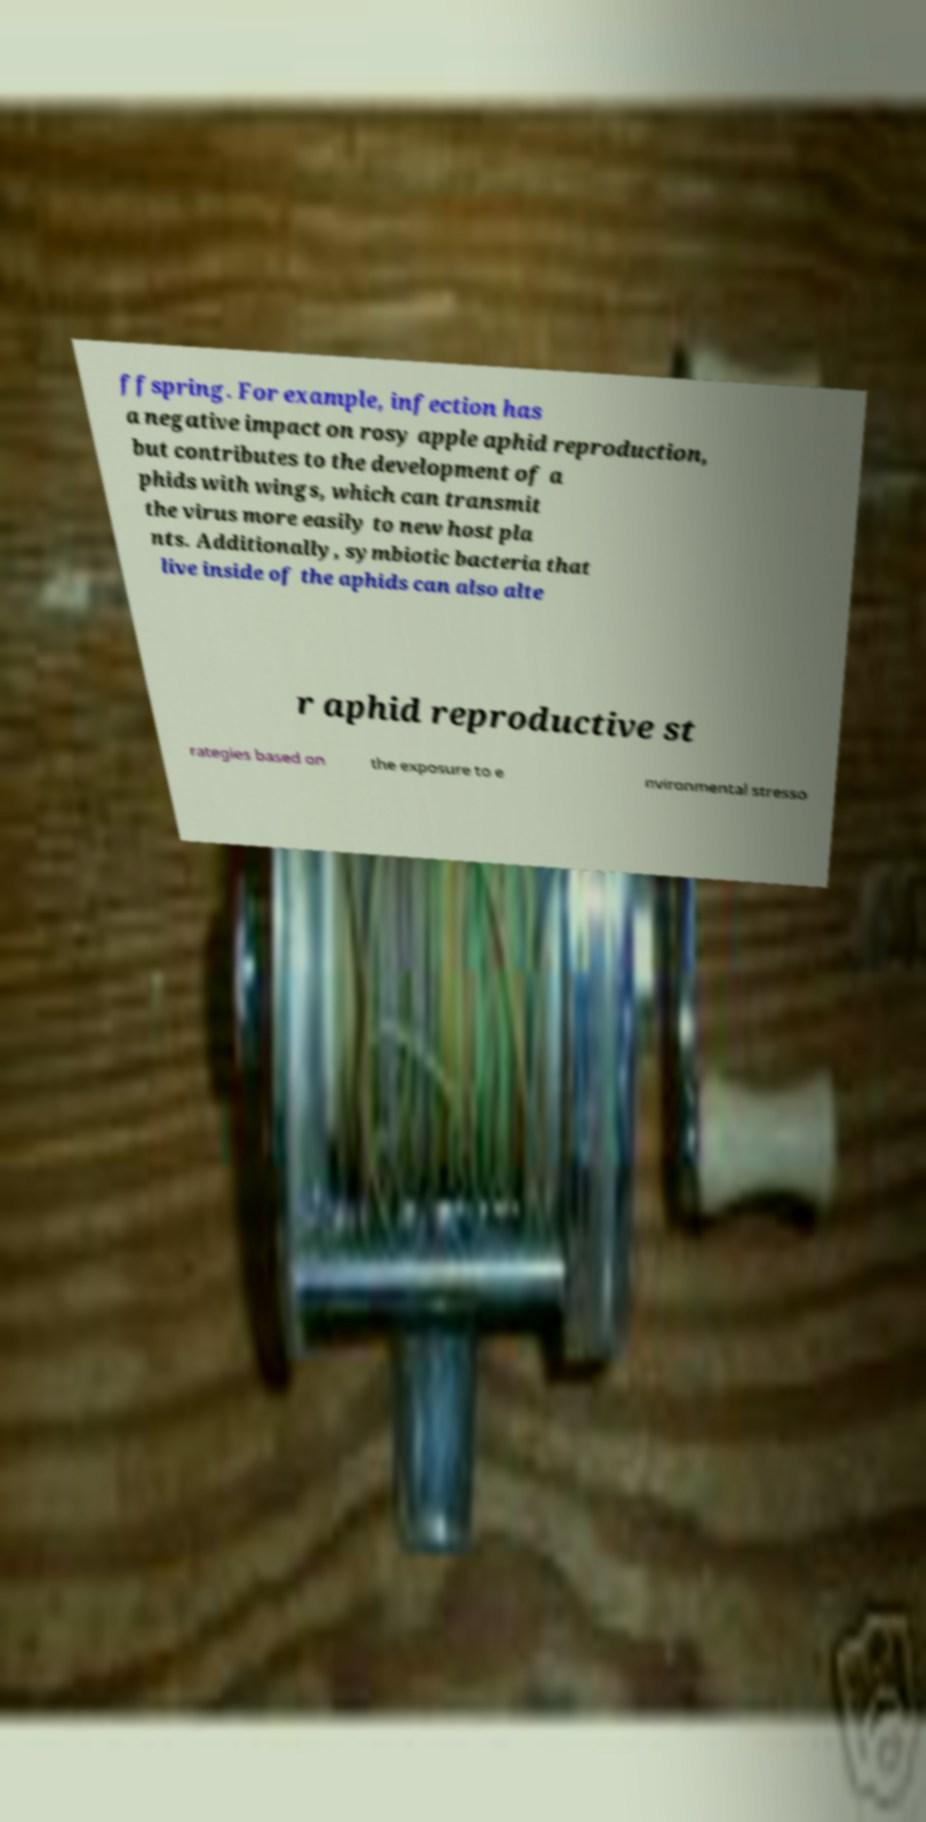What messages or text are displayed in this image? I need them in a readable, typed format. ffspring. For example, infection has a negative impact on rosy apple aphid reproduction, but contributes to the development of a phids with wings, which can transmit the virus more easily to new host pla nts. Additionally, symbiotic bacteria that live inside of the aphids can also alte r aphid reproductive st rategies based on the exposure to e nvironmental stresso 